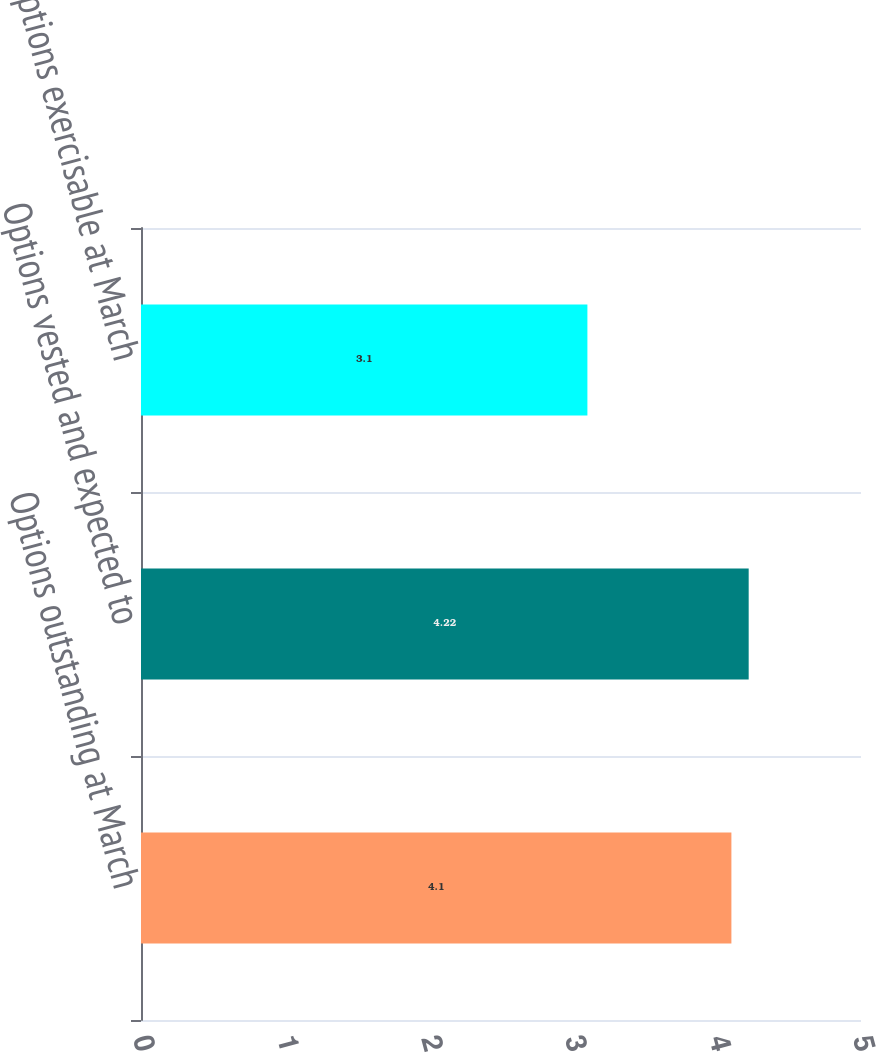<chart> <loc_0><loc_0><loc_500><loc_500><bar_chart><fcel>Options outstanding at March<fcel>Options vested and expected to<fcel>Options exercisable at March<nl><fcel>4.1<fcel>4.22<fcel>3.1<nl></chart> 